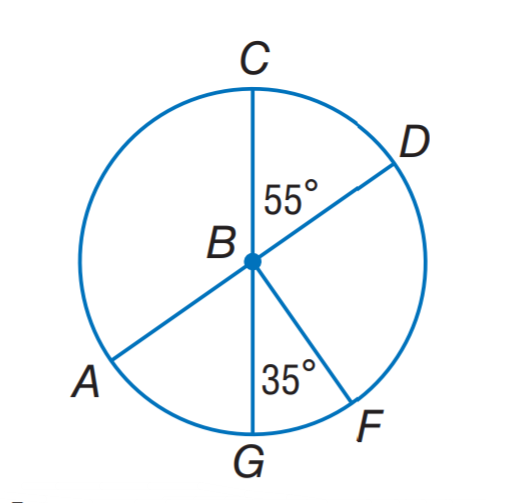Answer the mathemtical geometry problem and directly provide the correct option letter.
Question: A D and C G are diameters of \odot B. Find m \widehat C D.
Choices: A: 35 B: 45 C: 55 D: 65 C 